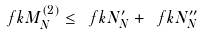Convert formula to latex. <formula><loc_0><loc_0><loc_500><loc_500>\ f k M _ { N } ^ { ( 2 ) } \leq \ f k N _ { N } ^ { \prime } + \ f k N _ { N } ^ { \prime \prime }</formula> 